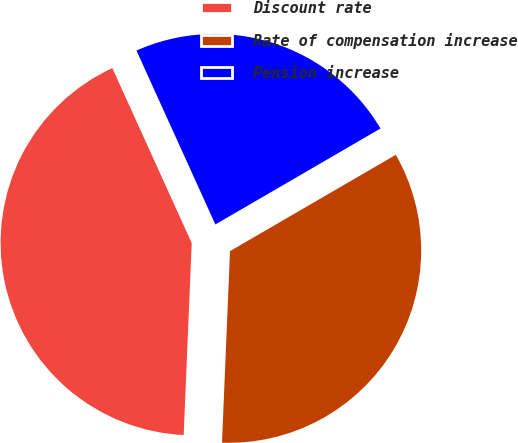Convert chart to OTSL. <chart><loc_0><loc_0><loc_500><loc_500><pie_chart><fcel>Discount rate<fcel>Rate of compensation increase<fcel>Pension increase<nl><fcel>42.55%<fcel>34.04%<fcel>23.4%<nl></chart> 